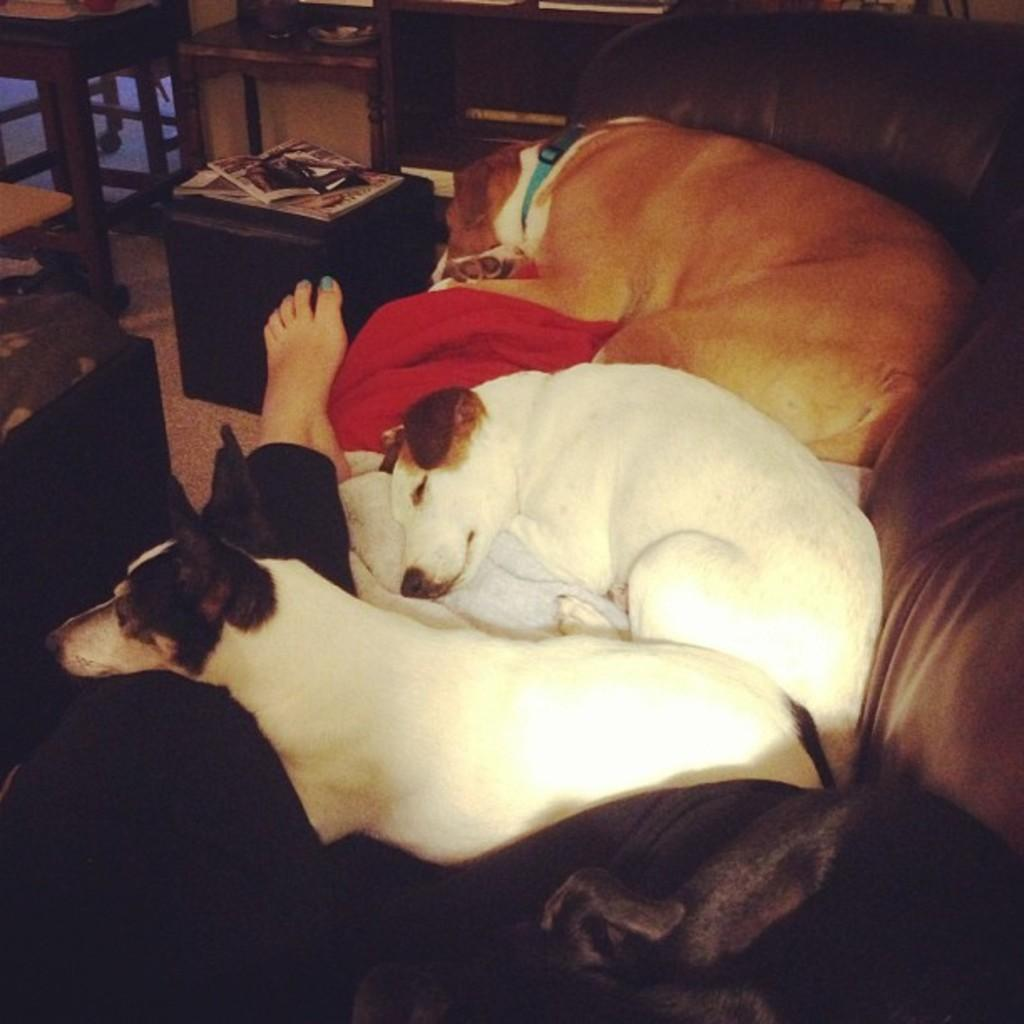What animals are lying in the image? There are dogs lying in the image. Can you describe any part of a person in the image? A person's leg is visible in the image. What is on the sofa in the image? There are clothes on a sofa. What is located near the sofa in the image? Books are present beside the sofa. What piece of furniture is in the image? There is a table in the image. What can be found on the floor in the image? There are objects on the floor. How does the person in the image measure the organization of the books? There is no indication in the image that the person is measuring the organization of the books. 